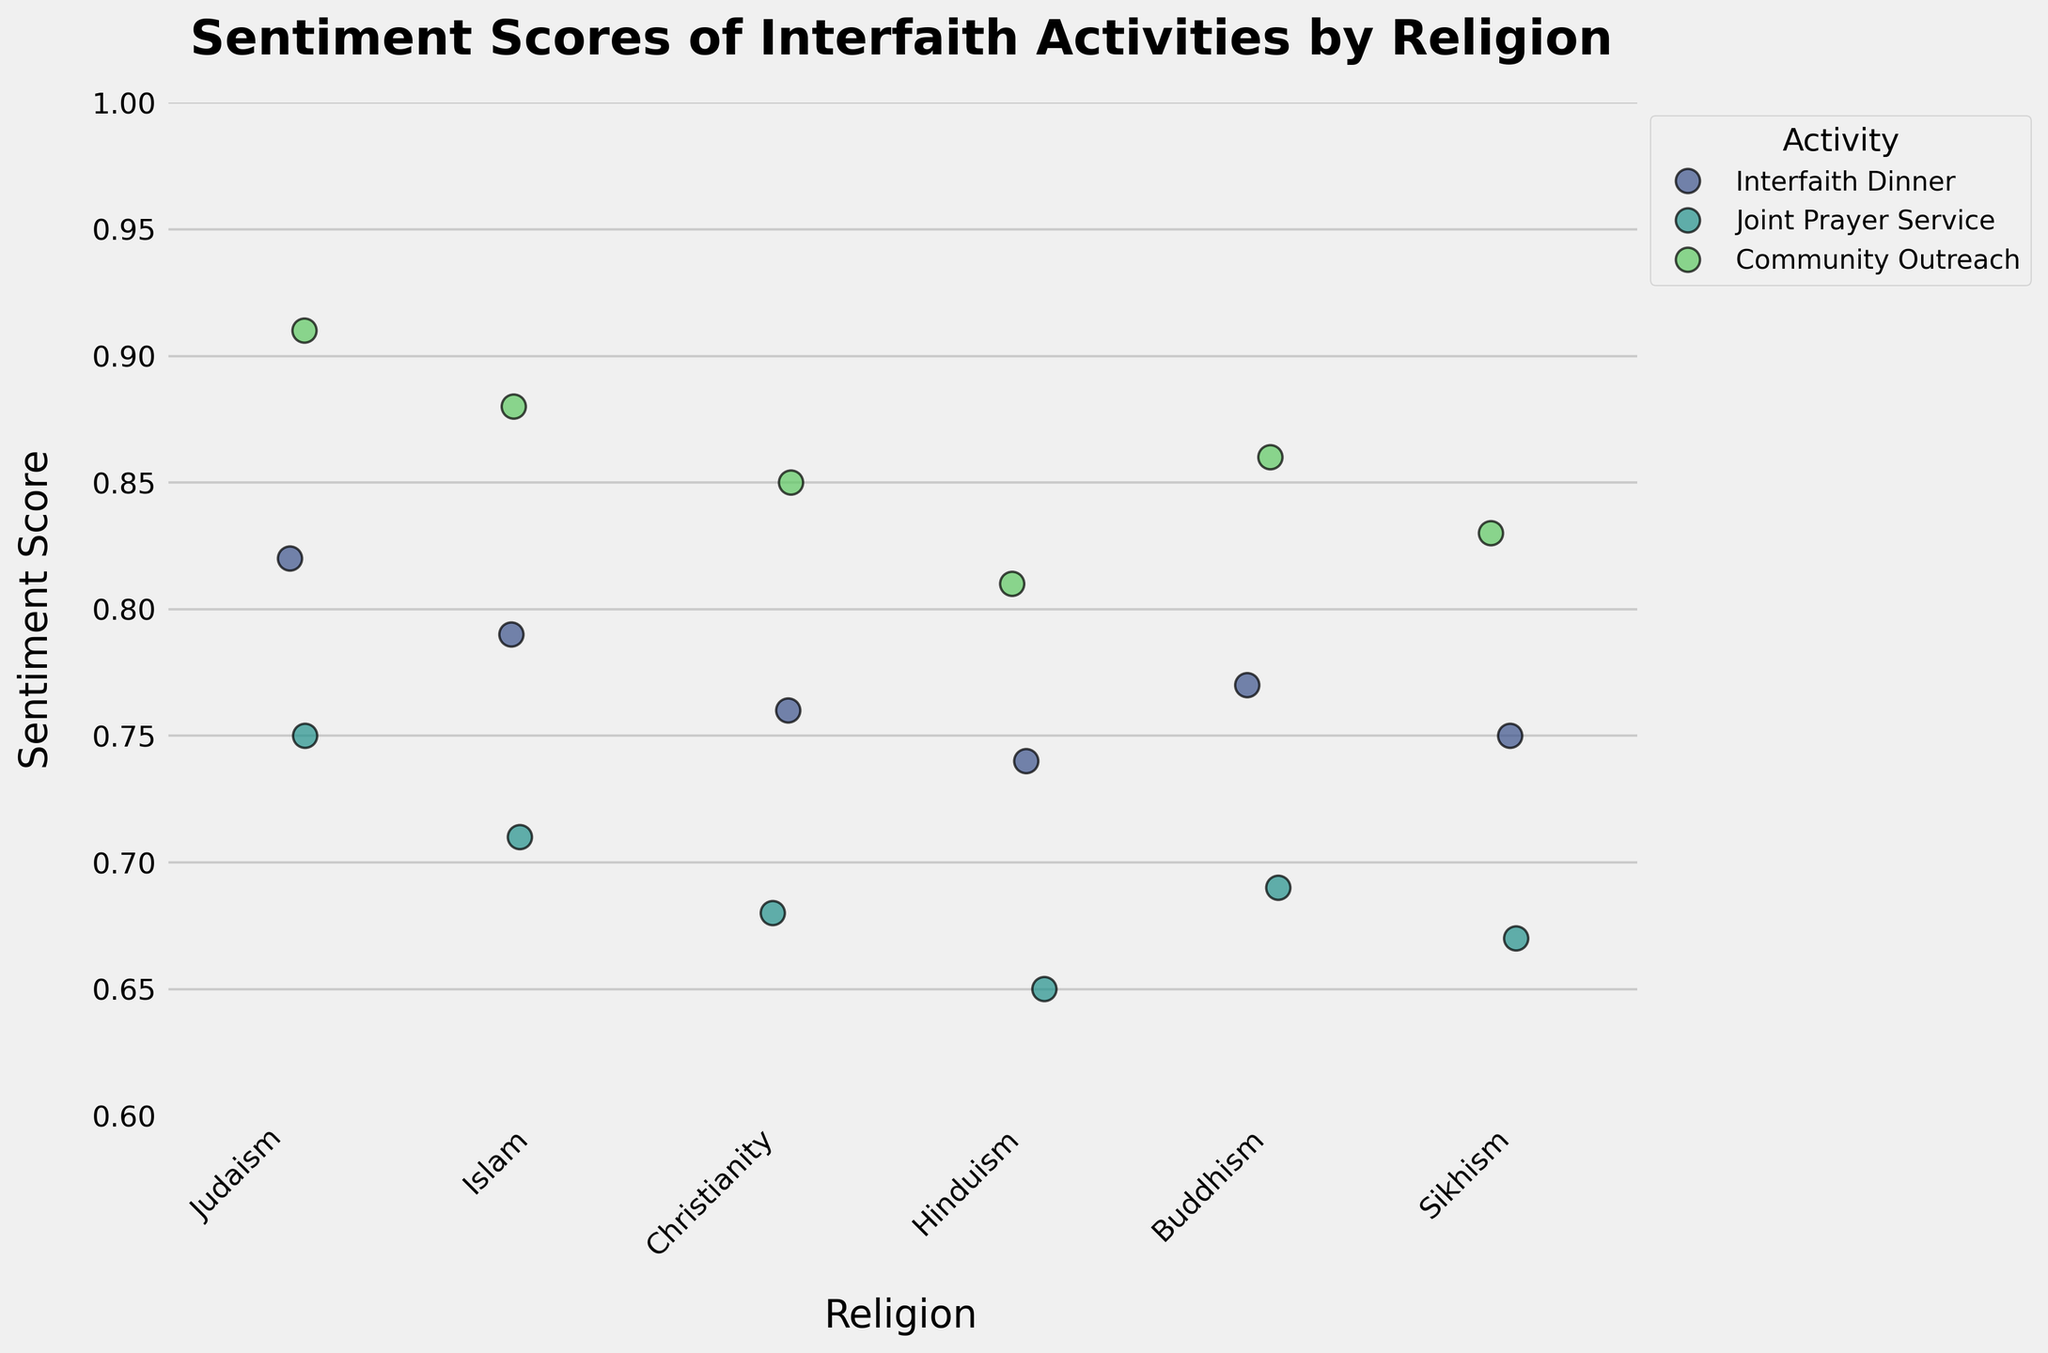What is the title of the plot? The title provides an overall idea of what the plot represents. Here, the title is located at the top of the plot in bold font.
Answer: Sentiment Scores of Interfaith Activities by Religion Which religion has the highest average sentiment score for interfaith activities? To determine this, examine the different sentiment scores for each religion and calculate their averages.
Answer: Judaism Which activity has the most consistent sentiment scores across all religions? Consistency can be determined by examining the spread (less jittering points) of sentiment scores for each activity across all religions.
Answer: Community Outreach What is the sentiment score range for Hinduism's Joint Prayer Service? To find the range, look at the minimum and maximum sentiment scores for Hinduism's Joint Prayer Service.
Answer: 0.65 to 0.65 (only one data point) Which religion has the lowest sentiment score for any interfaith activity? Scan through the data points and identify the lowest sentiment score and the corresponding religion.
Answer: Hinduism Compare the average sentiment scores for Interfaith Dinner between Christianity and Buddhism. Which is higher? Calculate the average sentiment score for each religion for Interfaith Dinner and compare them.
Answer: Buddhism Which interfaith activity, on average, receives the lowest sentiment score? Calculate the average sentiment score for each activity and identify the lowest.
Answer: Joint Prayer Service Are the sentiment scores for the Interfaith Dinner clustered closely together or widely spread out for any religion? Look at the distribution of sentiment scores specific to Interfaith Dinner across different religions to see if they are tightly clustered or widely spread.
Answer: Closely clustered How do sentiment scores for Community Outreach vary between Judaism and Islam? Compare the sentiment scores for Community Outreach for Judaism and Islam by looking at their respective points.
Answer: Judaism: 0.91, Islam: 0.88 What is the general trend observed in sentiment scores for Joint Prayer Services across different religions? Examine the sentiment scores for Joint Prayer Services across different religions and identify any trend or pattern.
Answer: Lower than other activities for most religions 